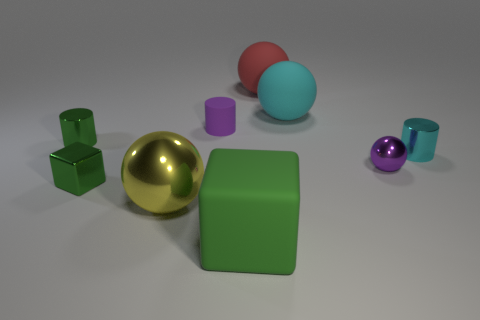Is the material of the tiny cube the same as the thing behind the cyan rubber object?
Offer a very short reply. No. Are there any yellow shiny objects on the right side of the large rubber sphere that is in front of the large red sphere?
Your response must be concise. No. What is the color of the small object that is both in front of the small cyan shiny thing and behind the tiny green block?
Provide a short and direct response. Purple. What size is the rubber cylinder?
Provide a short and direct response. Small. What number of cyan matte spheres are the same size as the green metallic cylinder?
Keep it short and to the point. 0. Do the ball that is left of the purple matte thing and the green block to the right of the tiny cube have the same material?
Offer a terse response. No. What is the small object that is right of the purple thing that is right of the big matte cube made of?
Make the answer very short. Metal. What material is the large ball that is in front of the tiny cyan metallic object?
Your answer should be very brief. Metal. What number of other big yellow metallic objects are the same shape as the yellow object?
Your answer should be very brief. 0. Does the metallic block have the same color as the matte block?
Keep it short and to the point. Yes. 